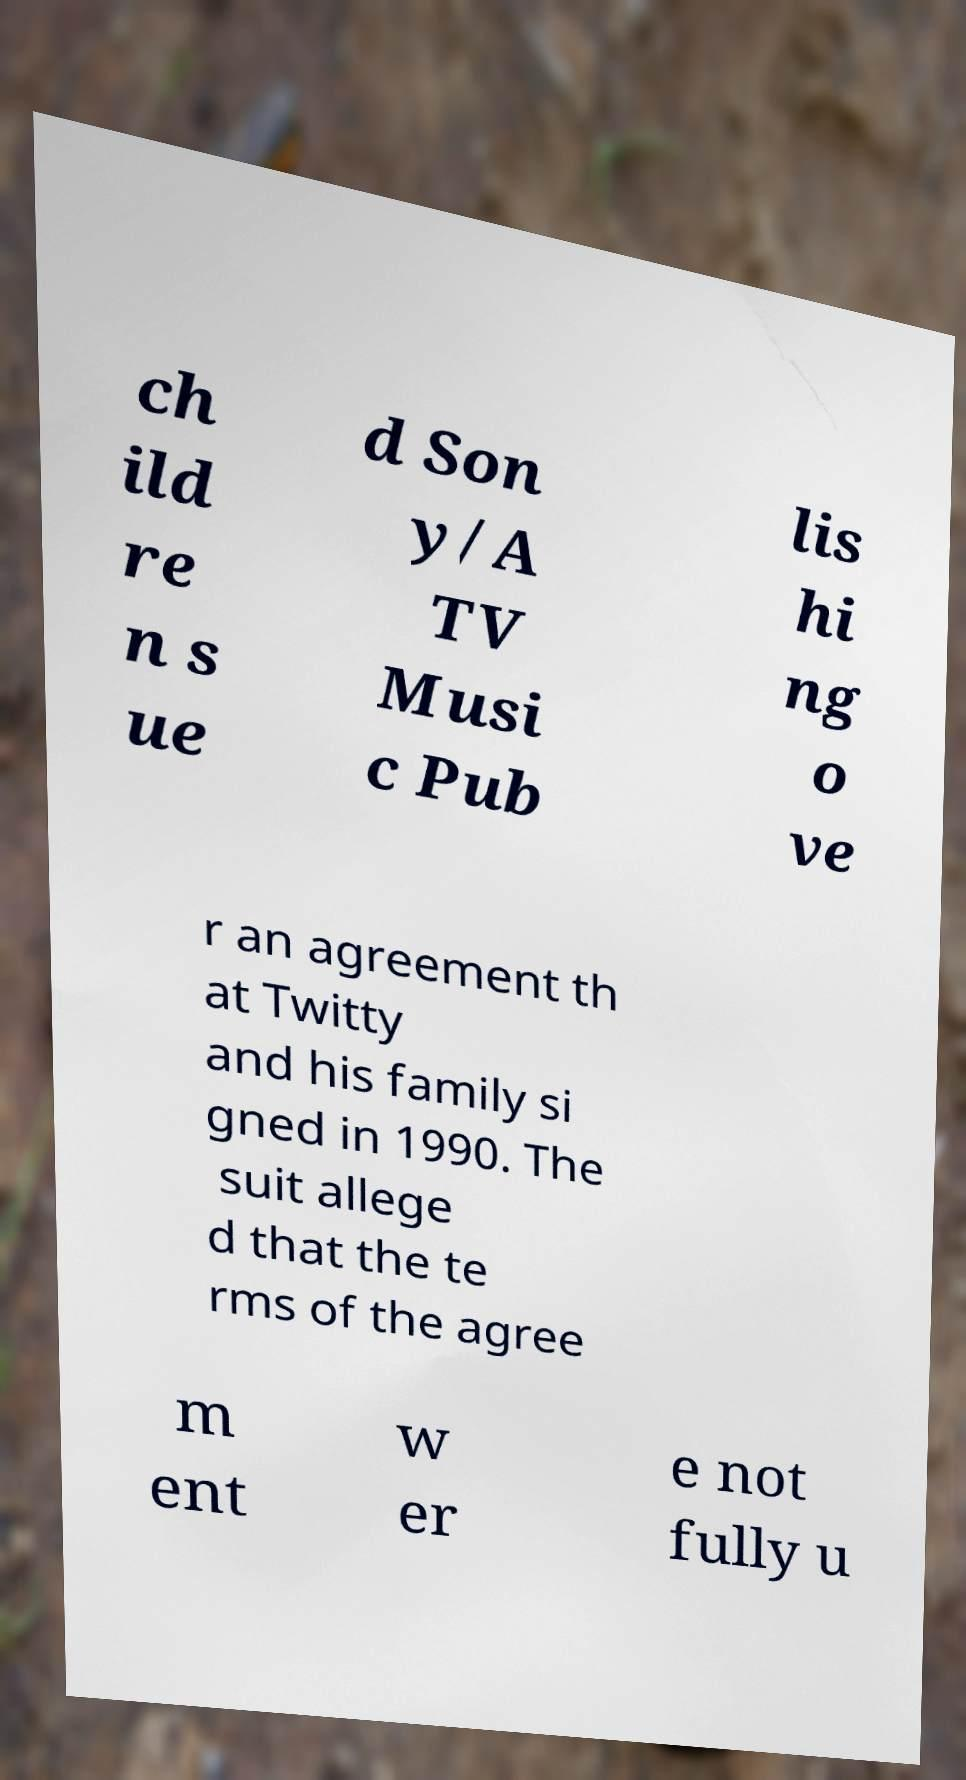For documentation purposes, I need the text within this image transcribed. Could you provide that? ch ild re n s ue d Son y/A TV Musi c Pub lis hi ng o ve r an agreement th at Twitty and his family si gned in 1990. The suit allege d that the te rms of the agree m ent w er e not fully u 